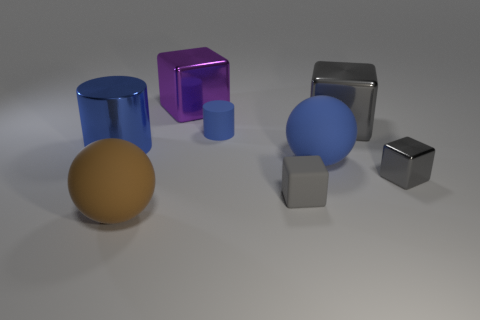How many gray cubes must be subtracted to get 1 gray cubes? 2 Subtract all matte cubes. How many cubes are left? 3 Subtract all brown cylinders. How many gray cubes are left? 3 Add 2 purple cylinders. How many objects exist? 10 Subtract all purple cubes. How many cubes are left? 3 Subtract all cylinders. How many objects are left? 6 Subtract all blue cubes. Subtract all yellow cylinders. How many cubes are left? 4 Add 1 large blue shiny cylinders. How many large blue shiny cylinders are left? 2 Add 8 big red cylinders. How many big red cylinders exist? 8 Subtract 0 green cylinders. How many objects are left? 8 